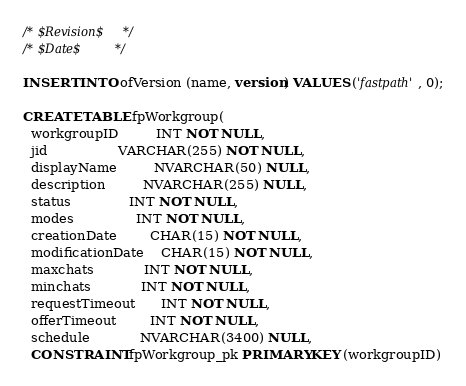Convert code to text. <code><loc_0><loc_0><loc_500><loc_500><_SQL_>/* $Revision$   */
/* $Date$       */

INSERT INTO ofVersion (name, version) VALUES ('fastpath', 0);

CREATE TABLE fpWorkgroup(
  workgroupID         INT NOT NULL,
  jid                 VARCHAR(255) NOT NULL,
  displayName         NVARCHAR(50) NULL,
  description         NVARCHAR(255) NULL,
  status              INT NOT NULL,
  modes               INT NOT NULL,
  creationDate        CHAR(15) NOT NULL,
  modificationDate    CHAR(15) NOT NULL,
  maxchats            INT NOT NULL,
  minchats            INT NOT NULL,
  requestTimeout      INT NOT NULL,
  offerTimeout        INT NOT NULL,
  schedule            NVARCHAR(3400) NULL,
  CONSTRAINT fpWorkgroup_pk PRIMARY KEY (workgroupID)</code> 